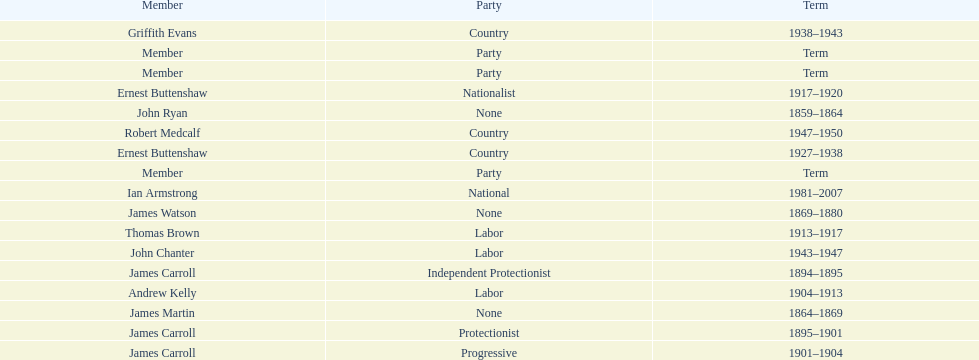Of the members of the third incarnation of the lachlan, who served the longest? Ernest Buttenshaw. 